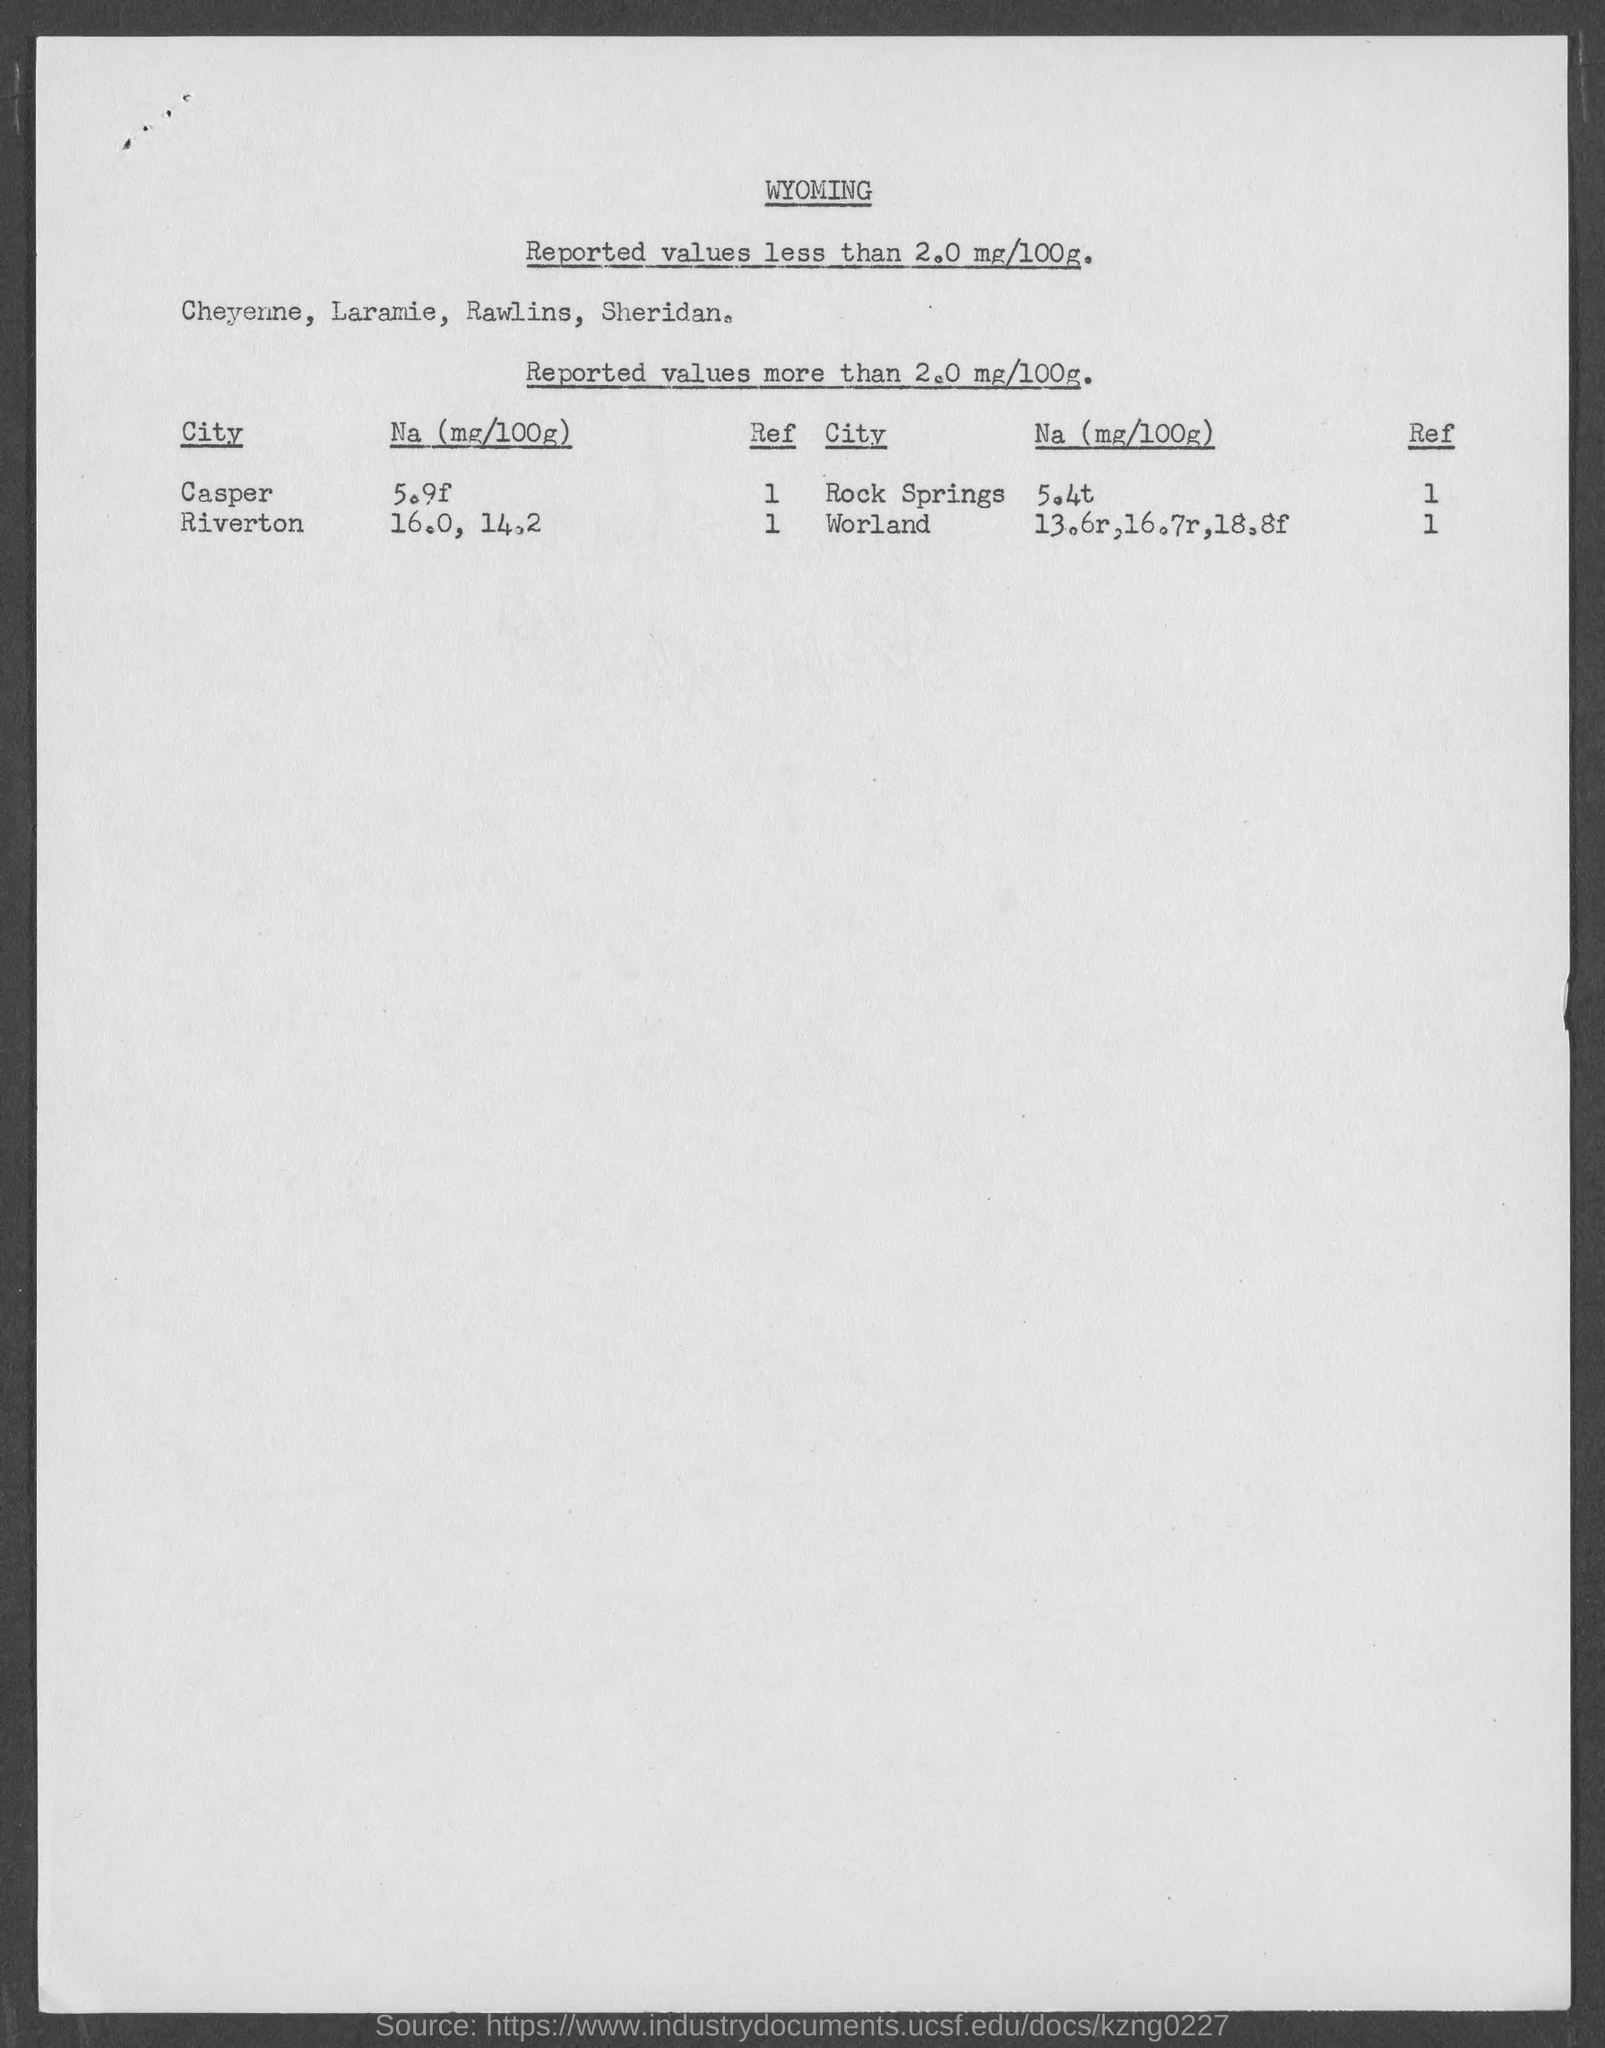Identify some key points in this picture. The ref value of the city Worland is 1. What is the value of the city Casper, represented as a number between 1 and . . .  The Na value for the city of Rock Springs is 5.4 grams per kilogram. The first title in the document is "Wyoming. The Na value for Casper, a city in the United States, is 5.9f. 